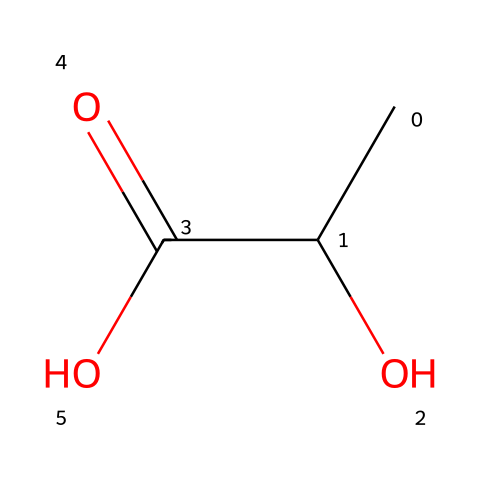How many carbon atoms are in lactic acid? The SMILES representation shows two carbon atoms (CC) present in the structure of lactic acid.
Answer: 2 What functional groups are present in lactic acid? The structure includes a hydroxyl group (-OH) and a carboxylic acid group (-COOH), which classify it as an alcohol and an acid.
Answer: alcohol, carboxylic acid Is lactic acid a chiral molecule? Lactic acid contains a carbon atom that is bonded to four different atoms or groups, making it chiral.
Answer: yes What is the molecular formula of lactic acid? By interpreting the SMILES notation, it is determined to have three carbons, six hydrogens, and three oxygens, leading to the molecular formula C3H6O3.
Answer: C3H6O3 Which isomer of lactic acid is relevant to the olive fermentation process? In the case of lactic acid, we refer to L-lactic acid which is the active form found during fermentation processes.
Answer: L-lactic acid How many stereoisomers can lactic acid have? Since lactic acid has one chiral center, it can have two stereoisomers (R and S configurations).
Answer: 2 